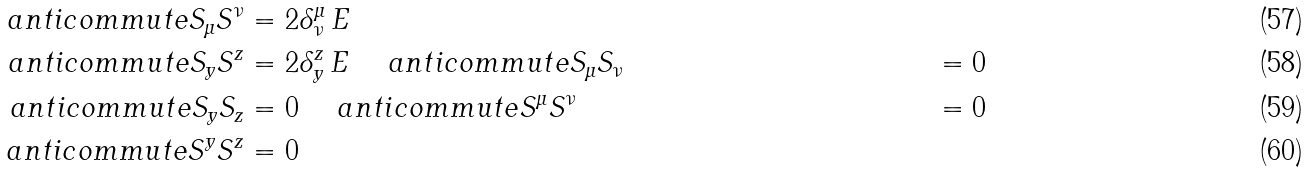Convert formula to latex. <formula><loc_0><loc_0><loc_500><loc_500>\ a n t i c o m m u t e { S _ { \mu } } { S ^ { \nu } } & = 2 \delta ^ { \mu } _ { \nu } \, E \\ \ a n t i c o m m u t e { S _ { y } } { S ^ { z } } & = 2 \delta ^ { z } _ { y } \, E \quad \ a n t i c o m m u t e { S _ { \mu } } { S _ { \nu } } & = 0 \\ \ a n t i c o m m u t e { S _ { y } } { S _ { z } } & = 0 \quad \ a n t i c o m m u t e { S ^ { \mu } } { S ^ { \nu } } & = 0 \\ \ a n t i c o m m u t e { S ^ { y } } { S ^ { z } } & = 0</formula> 